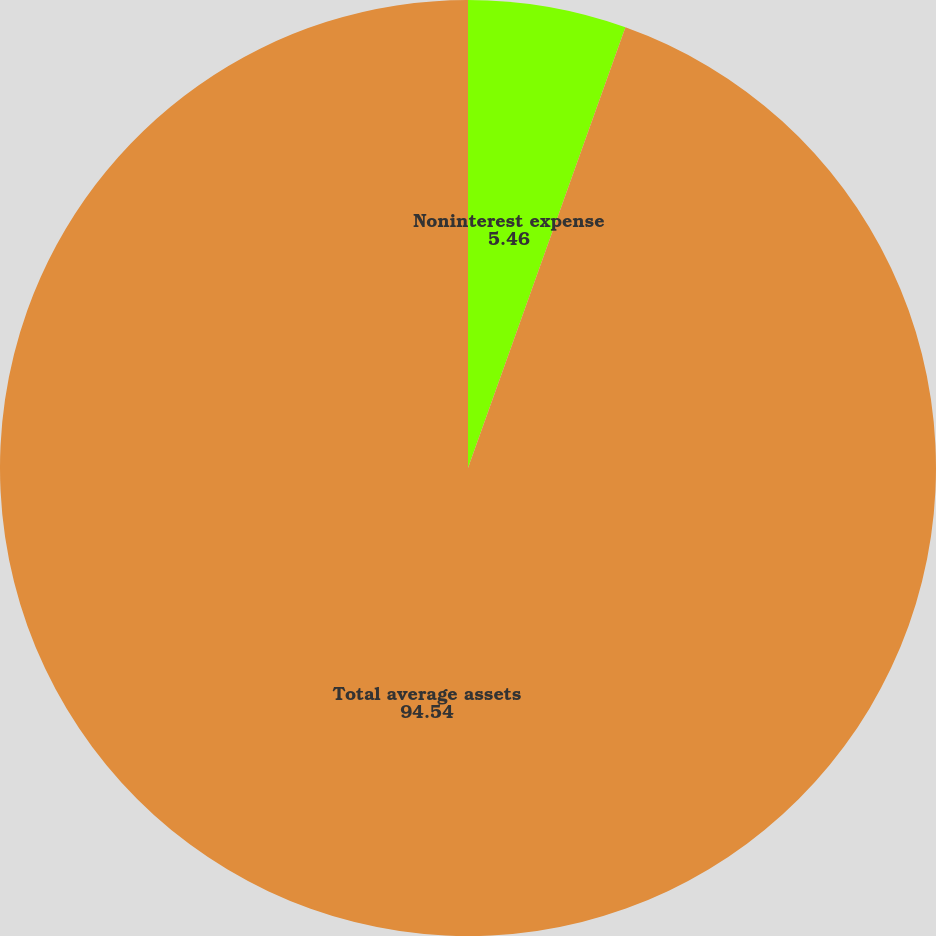Convert chart to OTSL. <chart><loc_0><loc_0><loc_500><loc_500><pie_chart><fcel>Noninterest expense<fcel>Total average assets<nl><fcel>5.46%<fcel>94.54%<nl></chart> 